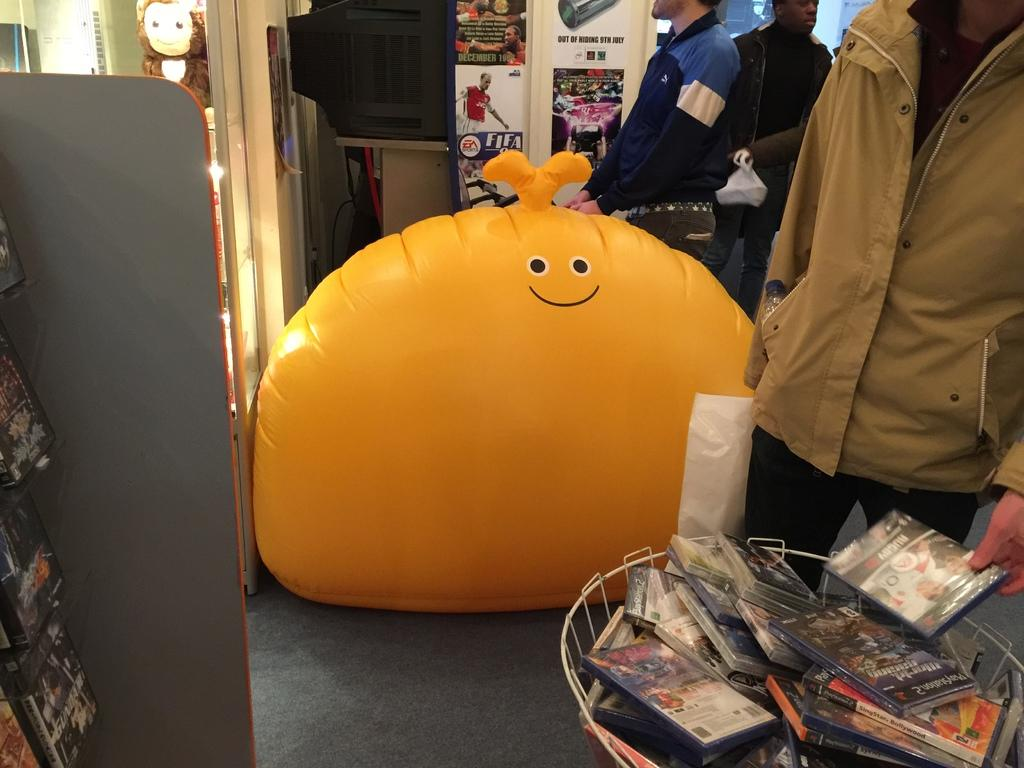<image>
Share a concise interpretation of the image provided. A large yellow inflatable infront of some game posters, including FIFA 